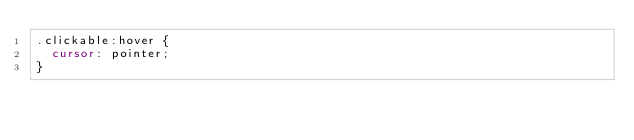<code> <loc_0><loc_0><loc_500><loc_500><_CSS_>.clickable:hover {
  cursor: pointer;
}
</code> 